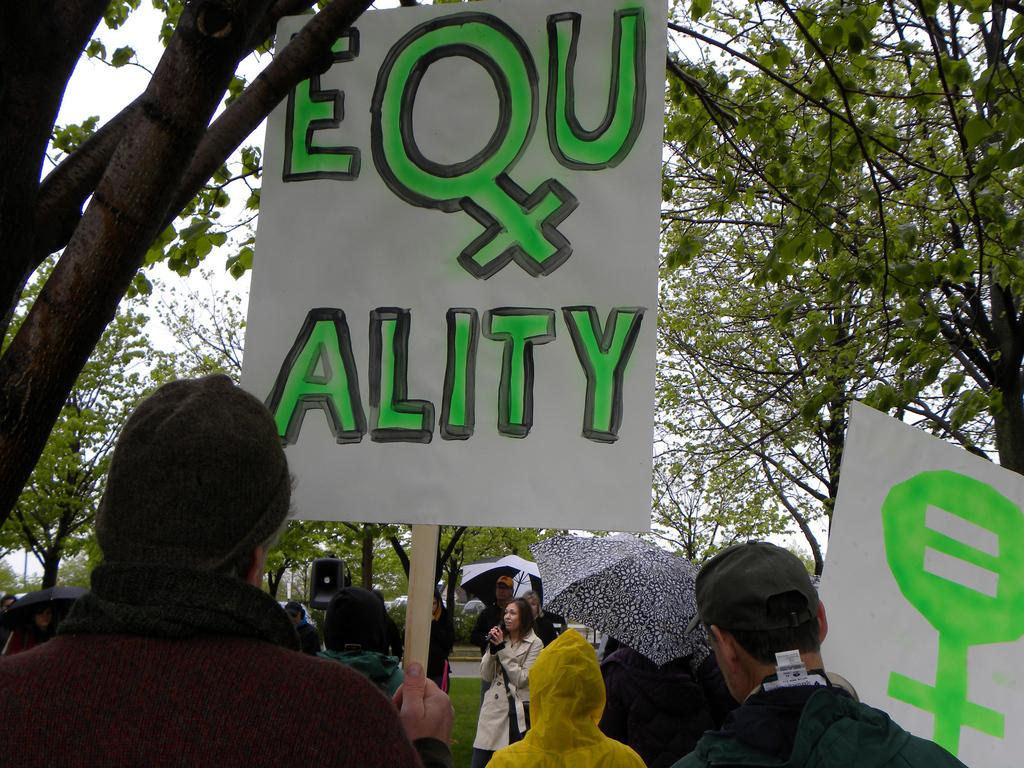Who are the subjects in the image? There are people in the image. What are the people holding in their hands? The people are holding flashcards. What activity are the people engaged in? The people are protesting. What can be seen in the background of the image? There are trees in the background of the image. What type of cable can be seen hanging from the trees in the image? There is no cable present in the image. 